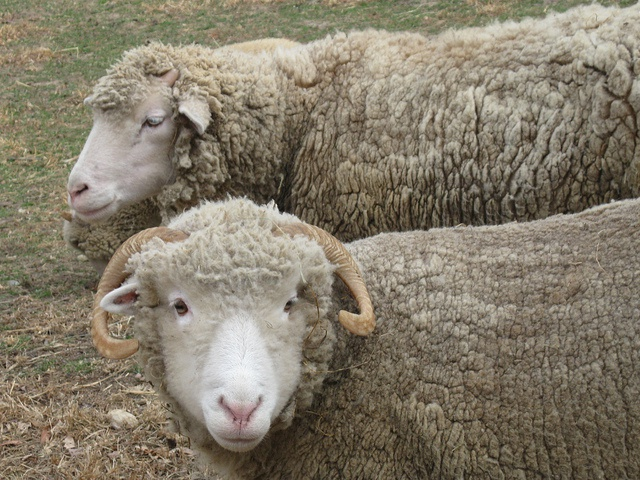Describe the objects in this image and their specific colors. I can see sheep in olive, gray, and darkgray tones and sheep in olive, darkgray, and gray tones in this image. 